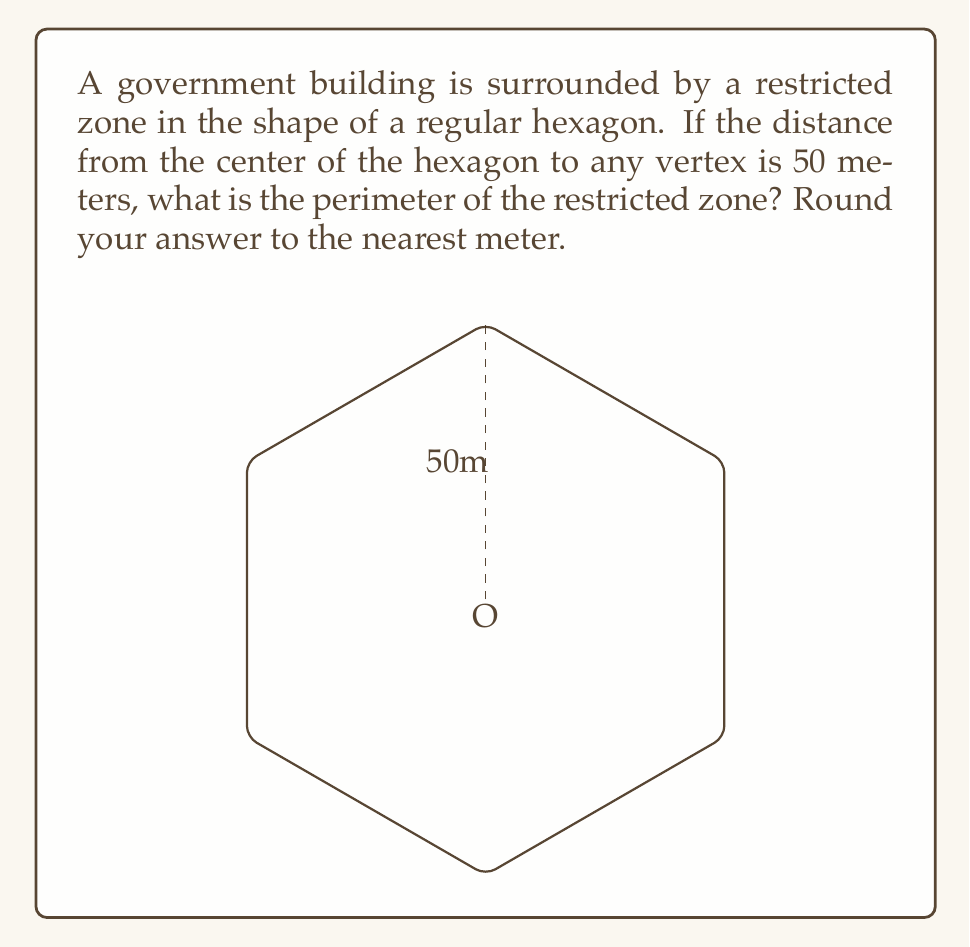Could you help me with this problem? Let's approach this step-by-step:

1) In a regular hexagon, the distance from the center to any vertex is equal to the side length. Let's call this distance $r$. Here, $r = 50$ meters.

2) The perimeter of a regular hexagon is equal to 6 times the side length. So, if we can find the side length, we can easily calculate the perimeter.

3) In a regular hexagon, each interior angle is 120°. This means that the triangle formed by two adjacent vertices and the center is equilateral.

4) In an equilateral triangle, the relationship between the side length $s$ and the radius $r$ of the circumscribed circle is:

   $$s = r\sqrt{3}$$

5) Substituting our known value:

   $$s = 50\sqrt{3}$$

6) Now we can calculate the perimeter $P$:

   $$P = 6s = 6(50\sqrt{3}) = 300\sqrt{3}$$

7) Evaluating this:

   $$300\sqrt{3} \approx 519.615$$

8) Rounding to the nearest meter:

   $$P \approx 520$$ meters
Answer: 520 meters 